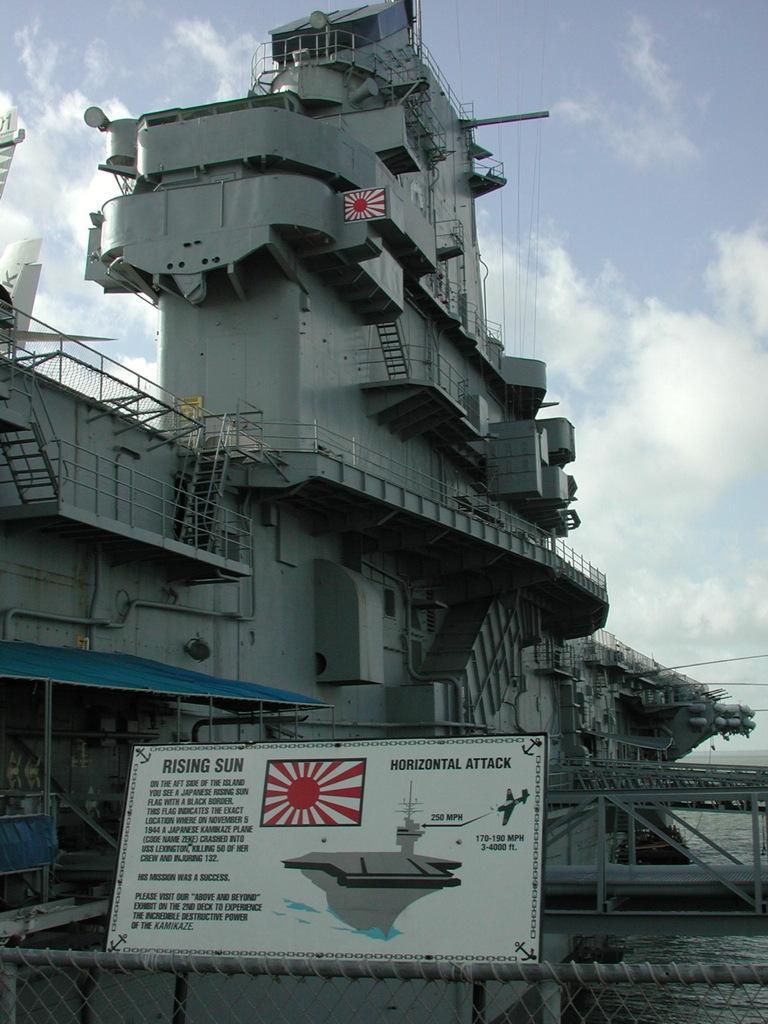Please provide a concise description of this image. In the center of the image, we can see a ship with stairs and there is a board. At the top, there are clouds in the sky. 